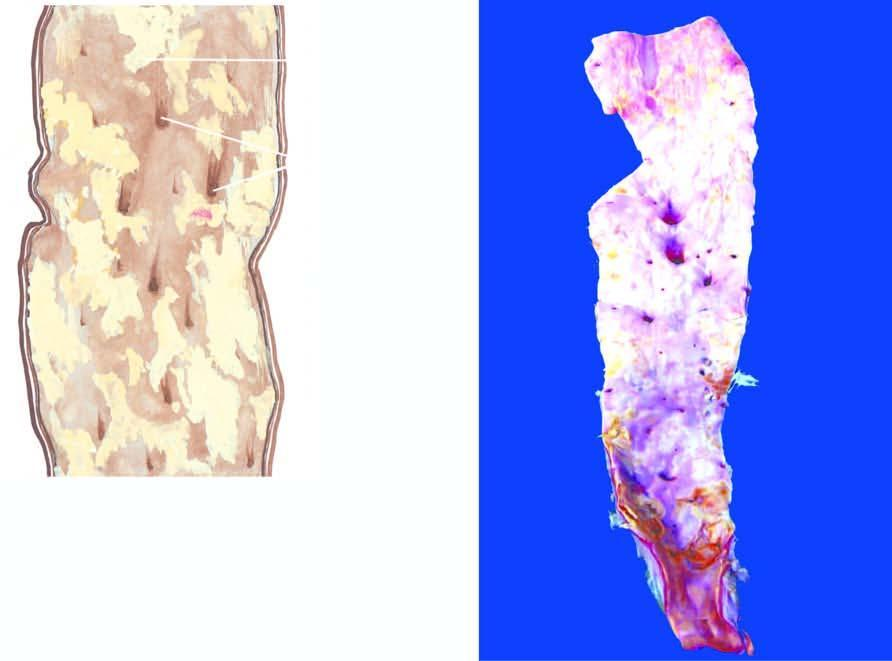where are yellowish-white lesions raised?
Answer the question using a single word or phrase. Above the surface 